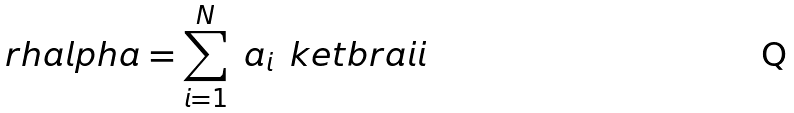Convert formula to latex. <formula><loc_0><loc_0><loc_500><loc_500>\ r h a l p h a = \sum _ { i = 1 } ^ { N } \ a _ { i } \, \ k e t b r a { i } { i }</formula> 